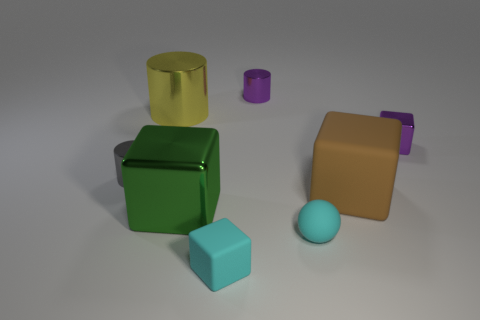What shape is the tiny object that is the same color as the matte ball?
Give a very brief answer. Cube. How many big things are yellow cylinders or brown matte things?
Provide a succinct answer. 2. What is the size of the gray thing?
Your response must be concise. Small. Is the size of the gray metallic cylinder the same as the block that is behind the gray metal thing?
Provide a succinct answer. Yes. How many cyan things are either small rubber balls or tiny matte things?
Keep it short and to the point. 2. How many big brown cubes are there?
Make the answer very short. 1. What size is the shiny cylinder to the right of the yellow object?
Keep it short and to the point. Small. Do the cyan rubber sphere and the purple cylinder have the same size?
Your response must be concise. Yes. What number of objects are small rubber cylinders or purple objects to the right of the big brown thing?
Offer a terse response. 1. What is the brown thing made of?
Give a very brief answer. Rubber. 